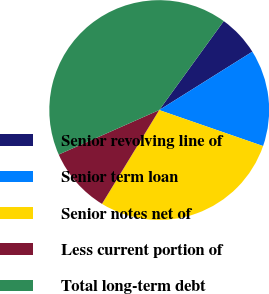Convert chart to OTSL. <chart><loc_0><loc_0><loc_500><loc_500><pie_chart><fcel>Senior revolving line of<fcel>Senior term loan<fcel>Senior notes net of<fcel>Less current portion of<fcel>Total long-term debt<nl><fcel>6.1%<fcel>14.22%<fcel>28.41%<fcel>9.65%<fcel>41.62%<nl></chart> 